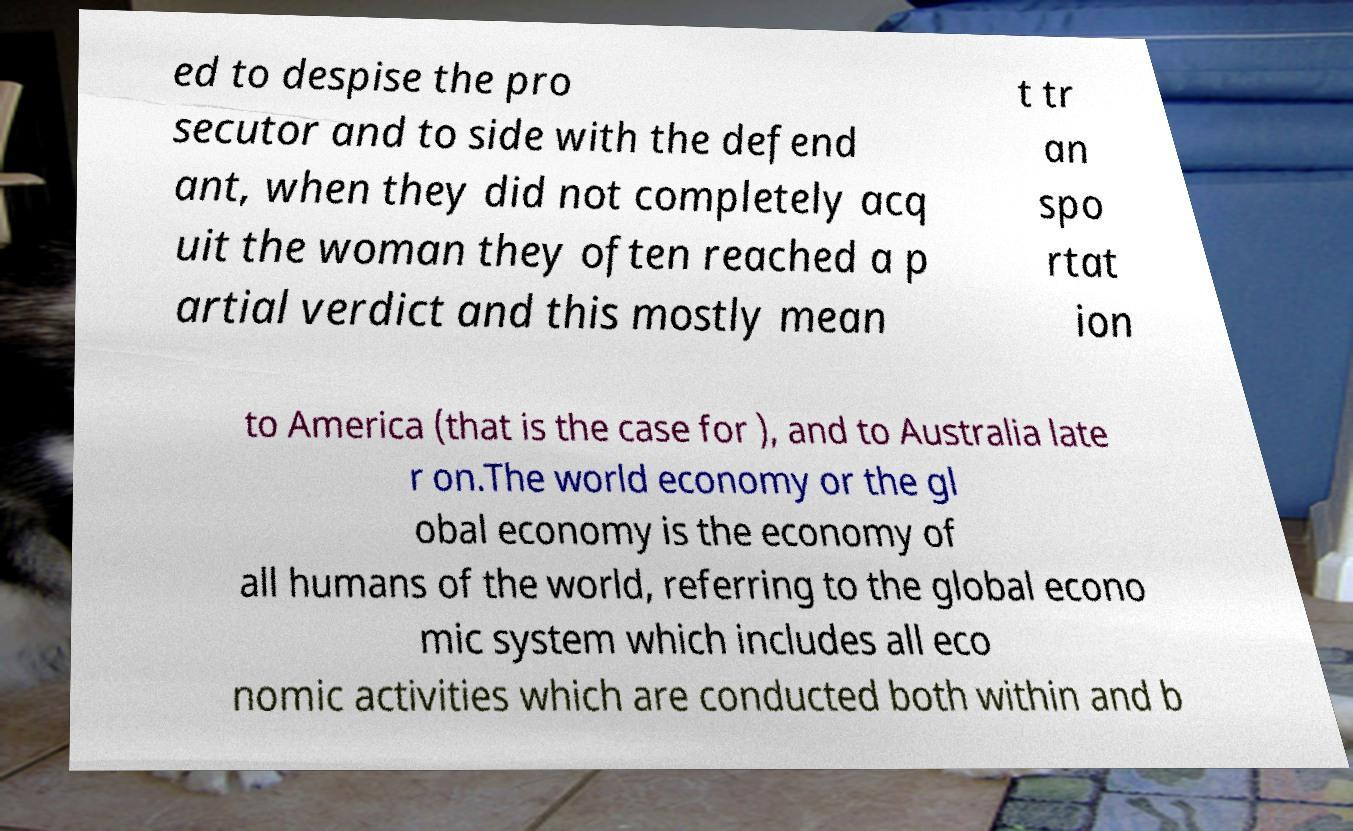Can you accurately transcribe the text from the provided image for me? ed to despise the pro secutor and to side with the defend ant, when they did not completely acq uit the woman they often reached a p artial verdict and this mostly mean t tr an spo rtat ion to America (that is the case for ), and to Australia late r on.The world economy or the gl obal economy is the economy of all humans of the world, referring to the global econo mic system which includes all eco nomic activities which are conducted both within and b 